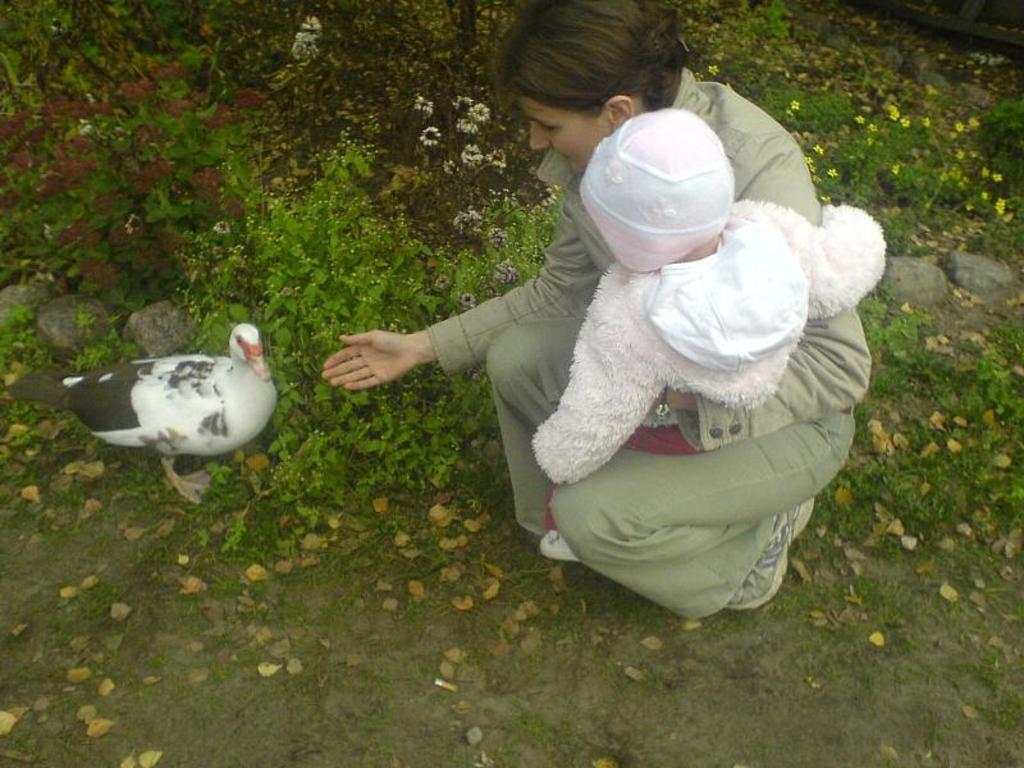Who is present in the image? There is a person and a child in the image. What type of animal can be seen in the image? There is a bird in the image. What natural elements are visible in the image? There are stones, flowers, and plants visible in the image. What hobbies does the father in the image enjoy? There is no mention of a father in the image, so we cannot determine any hobbies. 